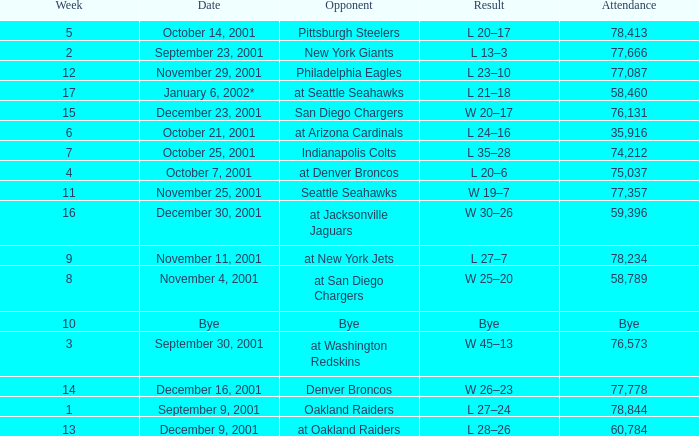What week is a bye week? 10.0. 